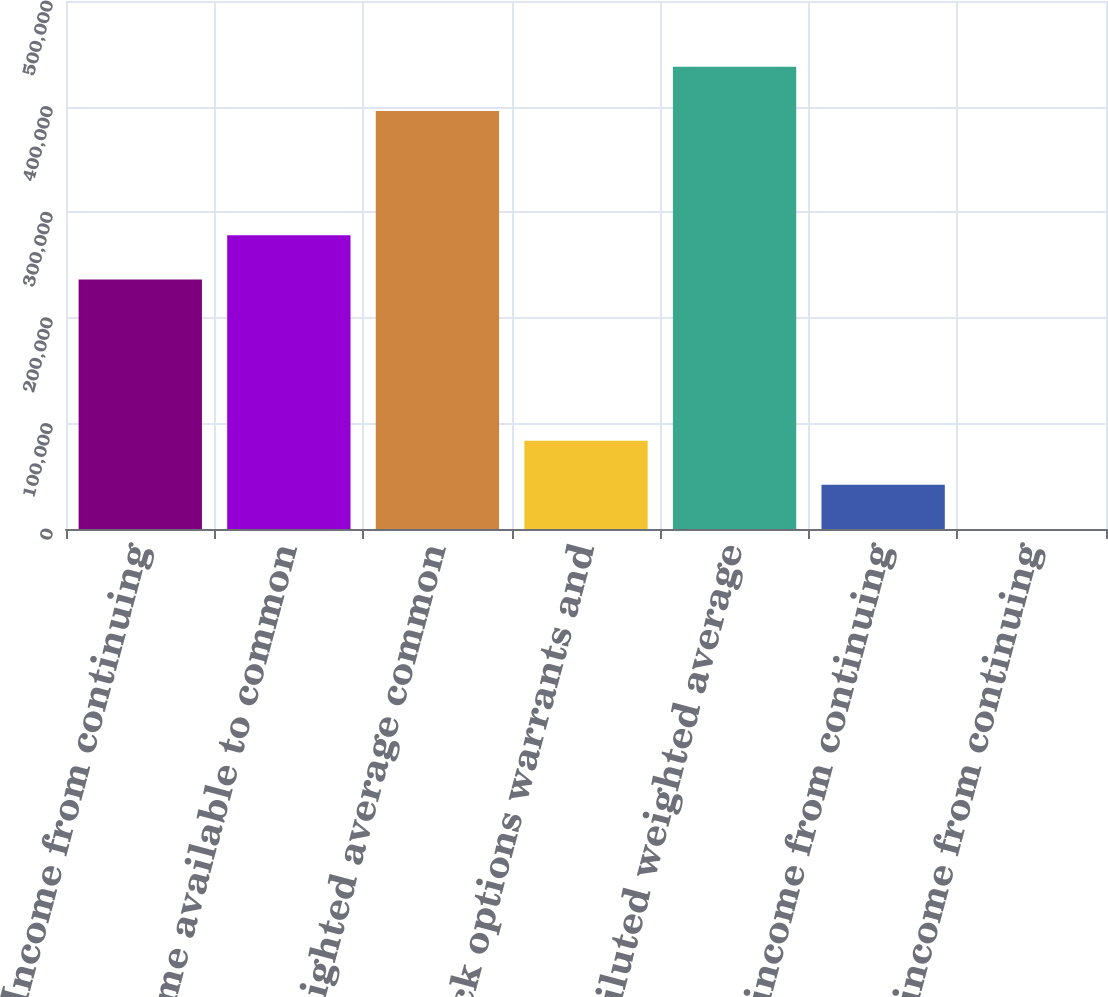Convert chart. <chart><loc_0><loc_0><loc_500><loc_500><bar_chart><fcel>Income from continuing<fcel>Income available to common<fcel>Basic weighted average common<fcel>Stock options warrants and<fcel>Diluted weighted average<fcel>Basic income from continuing<fcel>Diluted income from continuing<nl><fcel>236264<fcel>278100<fcel>395947<fcel>83671.9<fcel>437783<fcel>41836.2<fcel>0.58<nl></chart> 